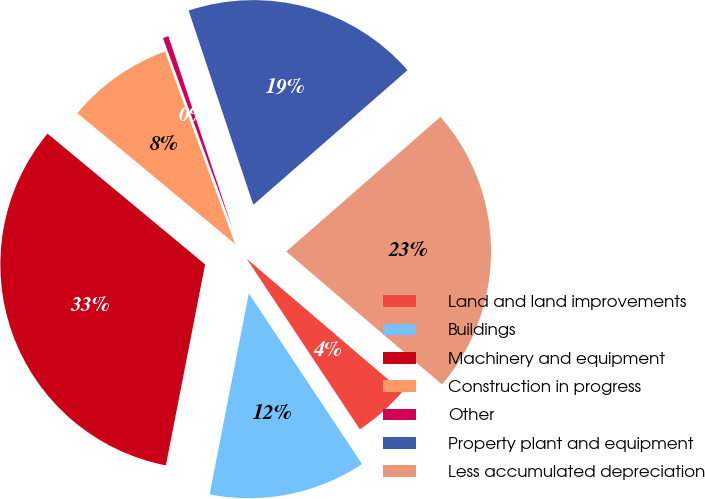Convert chart. <chart><loc_0><loc_0><loc_500><loc_500><pie_chart><fcel>Land and land improvements<fcel>Buildings<fcel>Machinery and equipment<fcel>Construction in progress<fcel>Other<fcel>Property plant and equipment<fcel>Less accumulated depreciation<nl><fcel>4.43%<fcel>12.39%<fcel>32.96%<fcel>8.41%<fcel>0.45%<fcel>18.69%<fcel>22.67%<nl></chart> 